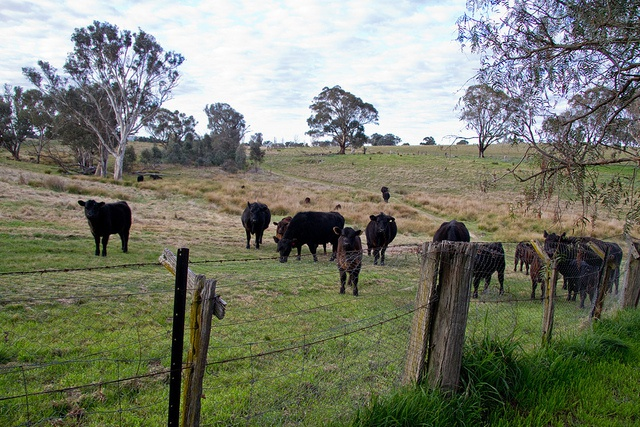Describe the objects in this image and their specific colors. I can see cow in lightgray, gray, and darkgray tones, cow in lightgray, black, and gray tones, cow in lightgray, black, gray, and darkgreen tones, cow in lightgray, black, gray, darkgray, and darkgreen tones, and cow in lightgray, black, and gray tones in this image. 